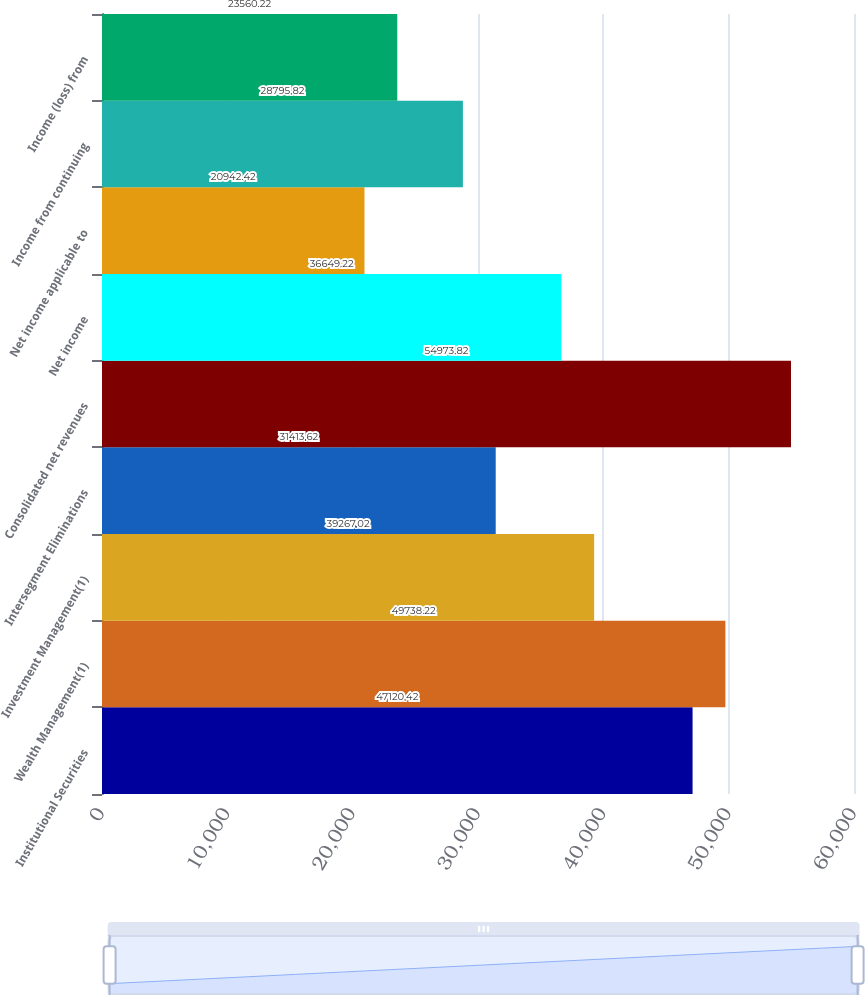Convert chart. <chart><loc_0><loc_0><loc_500><loc_500><bar_chart><fcel>Institutional Securities<fcel>Wealth Management(1)<fcel>Investment Management(1)<fcel>Intersegment Eliminations<fcel>Consolidated net revenues<fcel>Net income<fcel>Net income applicable to<fcel>Income from continuing<fcel>Income (loss) from<nl><fcel>47120.4<fcel>49738.2<fcel>39267<fcel>31413.6<fcel>54973.8<fcel>36649.2<fcel>20942.4<fcel>28795.8<fcel>23560.2<nl></chart> 